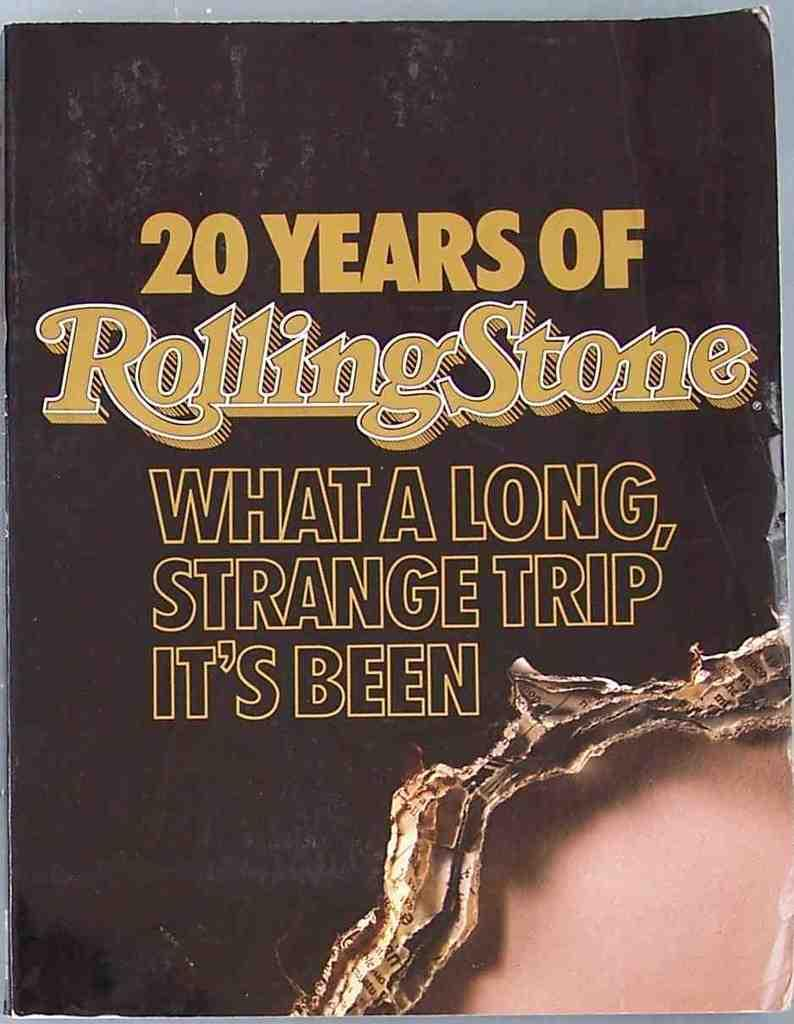<image>
Write a terse but informative summary of the picture. A copy of 20 Years of Rolling Stone with its tagline . 